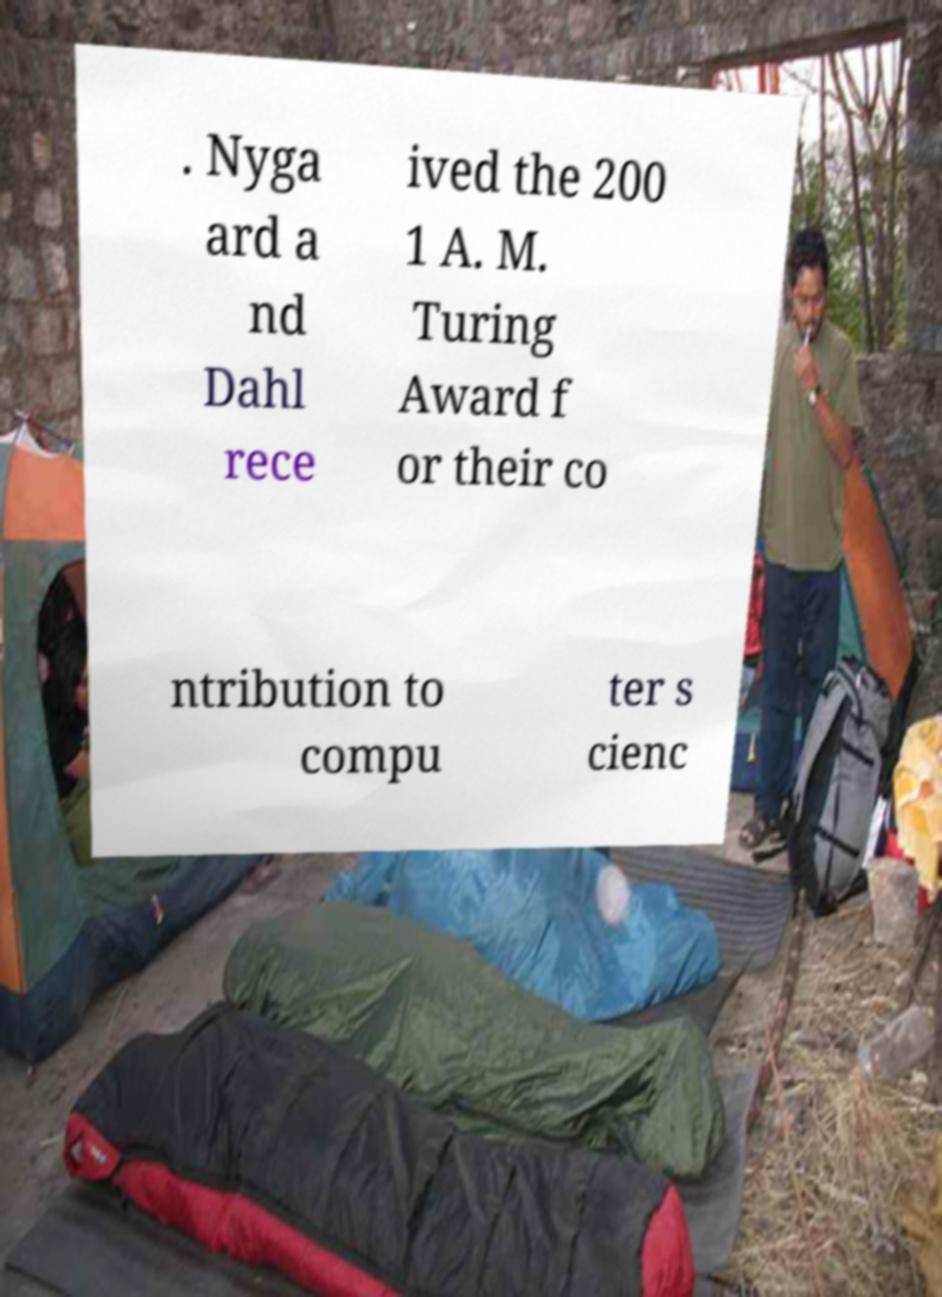What messages or text are displayed in this image? I need them in a readable, typed format. . Nyga ard a nd Dahl rece ived the 200 1 A. M. Turing Award f or their co ntribution to compu ter s cienc 